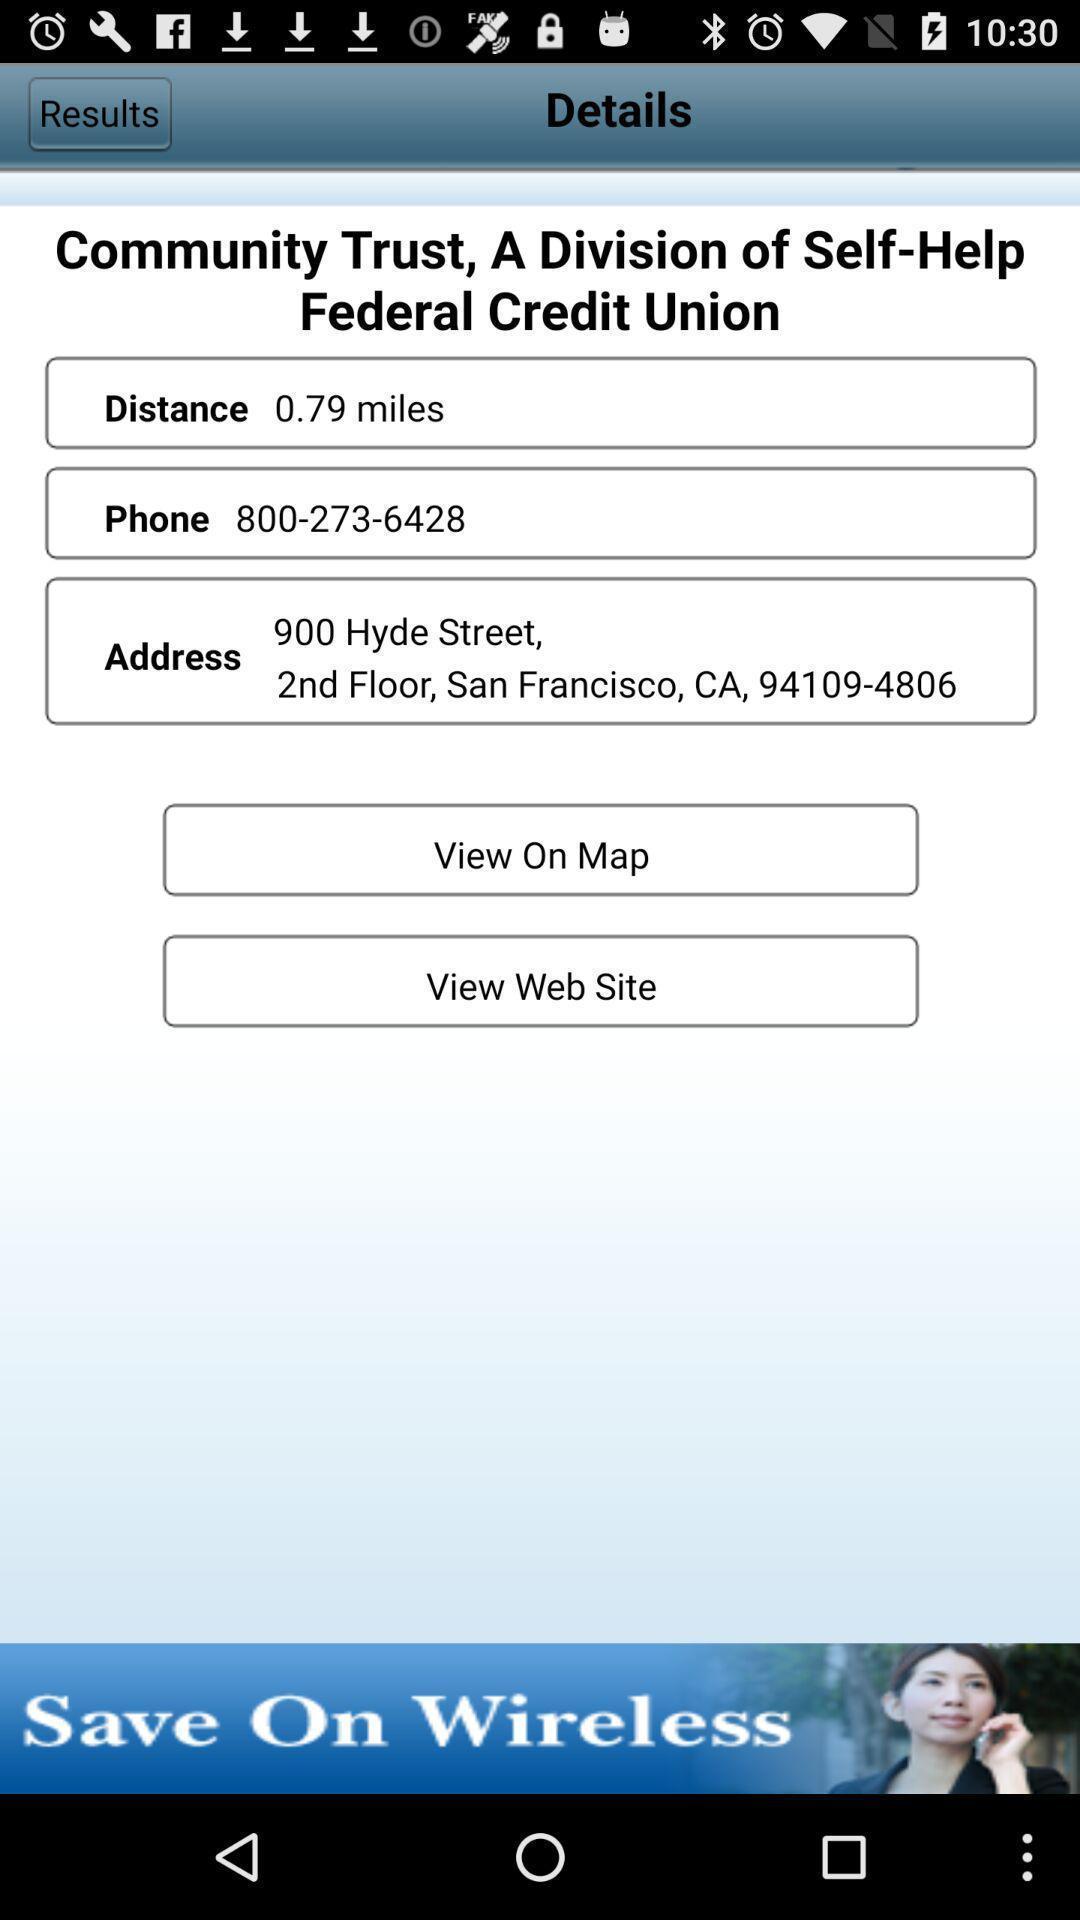What can you discern from this picture? Page showing the address field to add. 